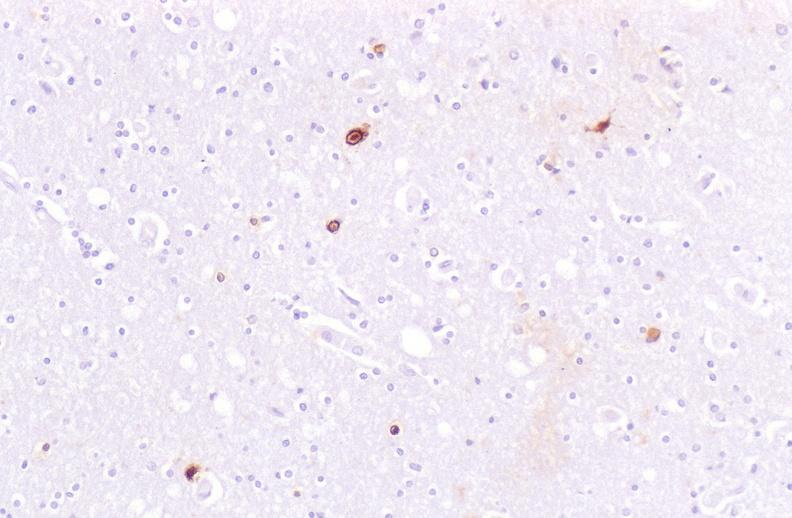s ameloblastoma present?
Answer the question using a single word or phrase. No 